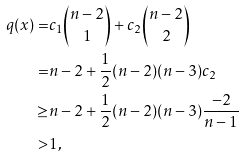<formula> <loc_0><loc_0><loc_500><loc_500>q ( x ) = & c _ { 1 } { n - 2 \choose 1 } + c _ { 2 } { n - 2 \choose 2 } \\ = & n - 2 + \frac { 1 } { 2 } ( n - 2 ) ( n - 3 ) c _ { 2 } \\ \geq & n - 2 + \frac { 1 } { 2 } ( n - 2 ) ( n - 3 ) \frac { - 2 } { n - 1 } \\ > & 1 ,</formula> 